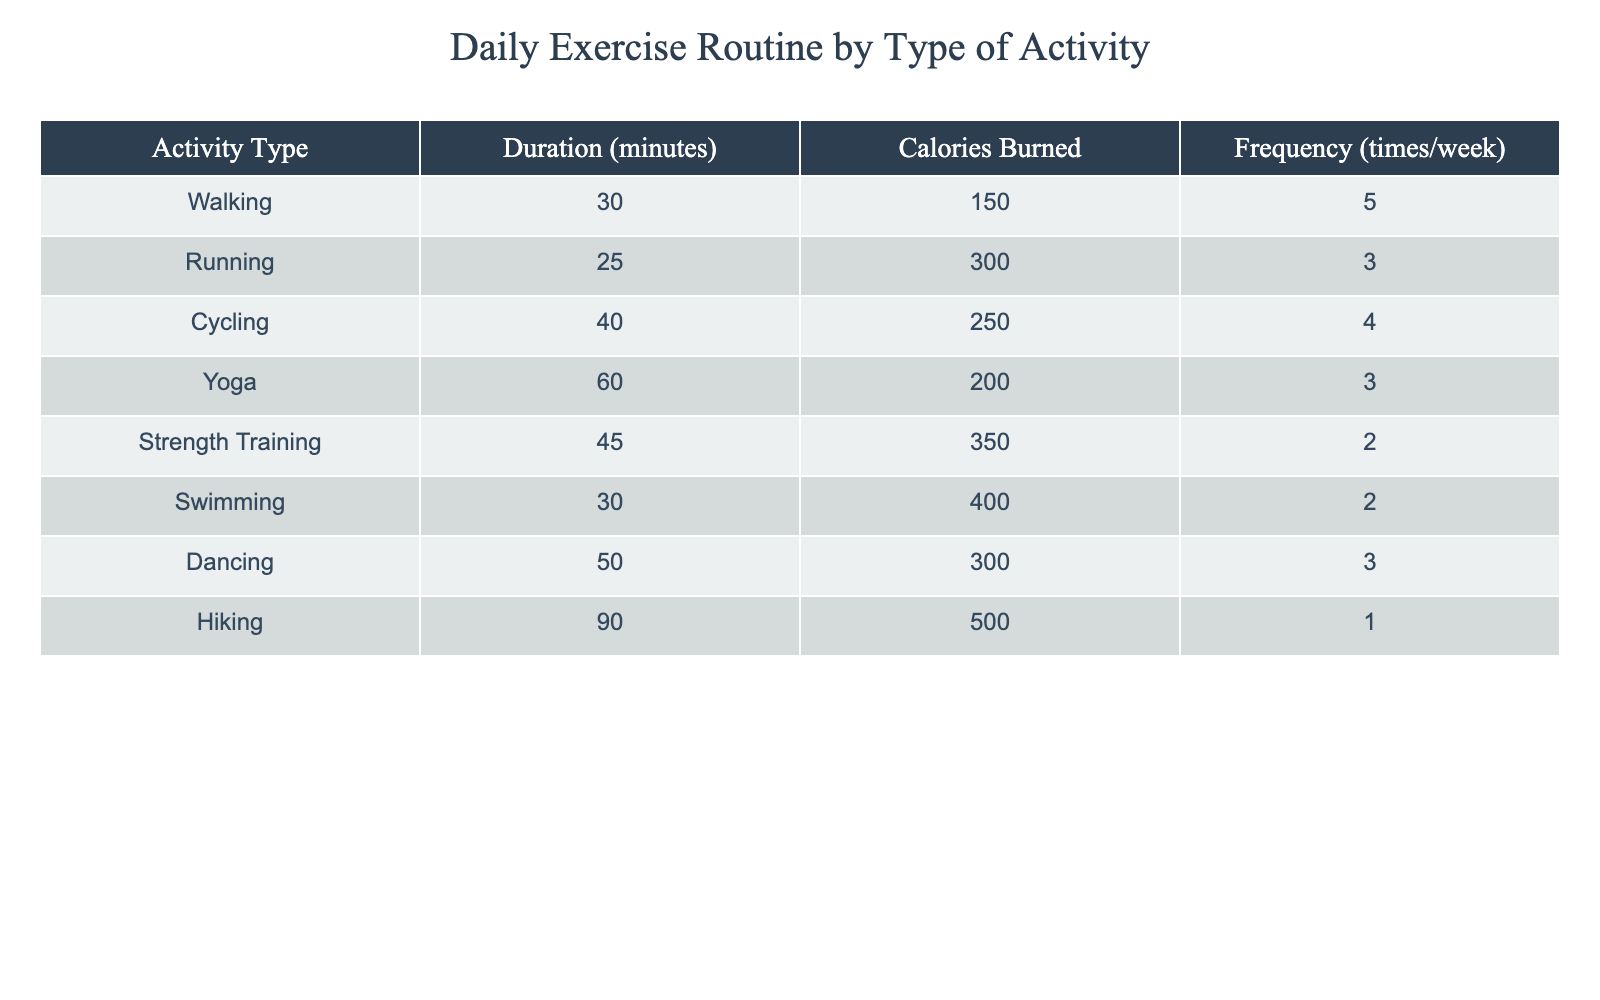What is the duration of the Yoga activity? The table lists the duration for each activity type. For Yoga, the Duration (minutes) column shows a value of 60 minutes.
Answer: 60 minutes How many calories are burned during Cycling? By referring to the table, the Calories Burned column for Cycling indicates that 250 calories are burned.
Answer: 250 calories Which activity has the highest frequency per week? Looking at the Frequency (times/week) column, Walking is listed with a frequency of 5 times per week, which is higher than any other activity.
Answer: Walking What is the average duration of all activities listed? To find the average duration, add the durations: 30 + 25 + 40 + 60 + 45 + 30 + 50 + 90 = 370, then divide by the number of activities (8). So, 370/8 = 46.25 minutes.
Answer: 46.25 minutes Is Swimming more effective than Strength Training in terms of calories burned per minute? To find this, calculate calories burned per minute for both: Swimming burns 400 calories in 30 minutes (13.33 calories/min) and Strength Training burns 350 calories in 45 minutes (7.78 calories/min). Therefore, Swimming is more effective.
Answer: Yes How many total calories are burned if someone does each activity according to their frequency for one week? Calculate as follows: (150 * 5) + (300 * 3) + (250 * 4) + (200 * 3) + (350 * 2) + (400 * 2) + (300 * 3) + (500 * 1) = 750 + 900 + 1000 + 600 + 700 + 800 + 900 + 500 = 5150 calories.
Answer: 5150 calories What percentage of the total frequency does Running account for? First, find the total frequency: 5 + 3 + 4 + 3 + 2 + 2 + 3 + 1 = 23. Running has a frequency of 3. So, the percentage is (3/23) * 100 = 13.04%.
Answer: 13.04% Which activity has the lowest calories burned, and how many calories does it burn? The table shows that Hiking burns 500 calories, which is the lowest value compared to others. Looking at the Calories Burned column confirms this.
Answer: 500 calories Does Dancing have a longer duration than Running? Referring to the table, Dancing has a duration of 50 minutes and Running has a duration of 25 minutes, indicating that Dancing indeed has a longer duration.
Answer: Yes 